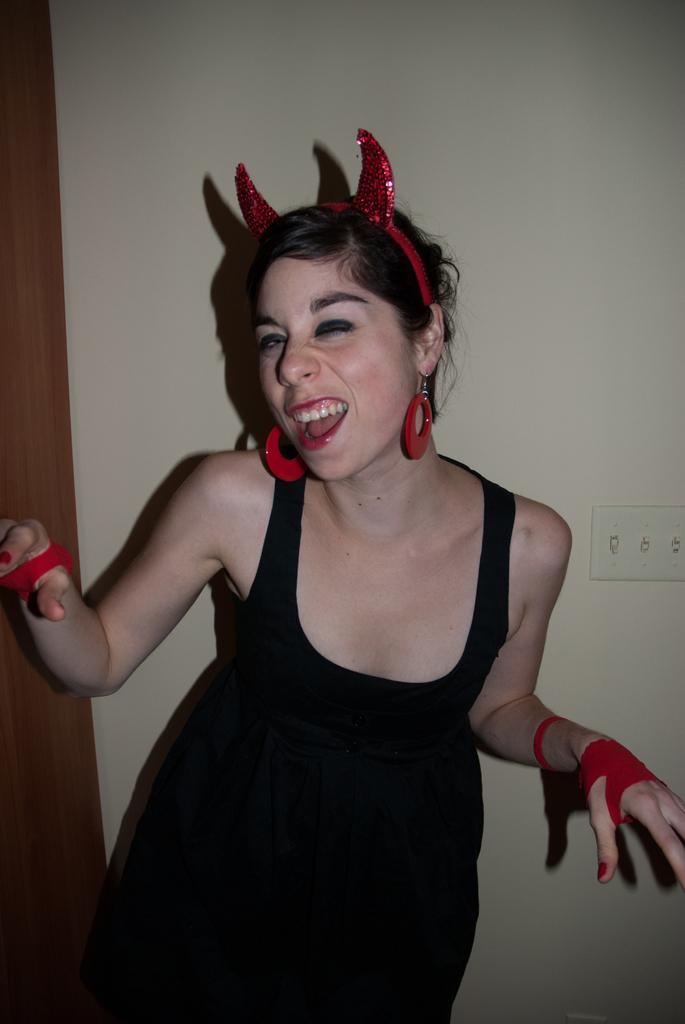Describe this image in one or two sentences. In this picture, there is a woman in the center wearing black clothes. She is also wearing red hair band, red earrings and red gloves. In the background, there is a wall. 